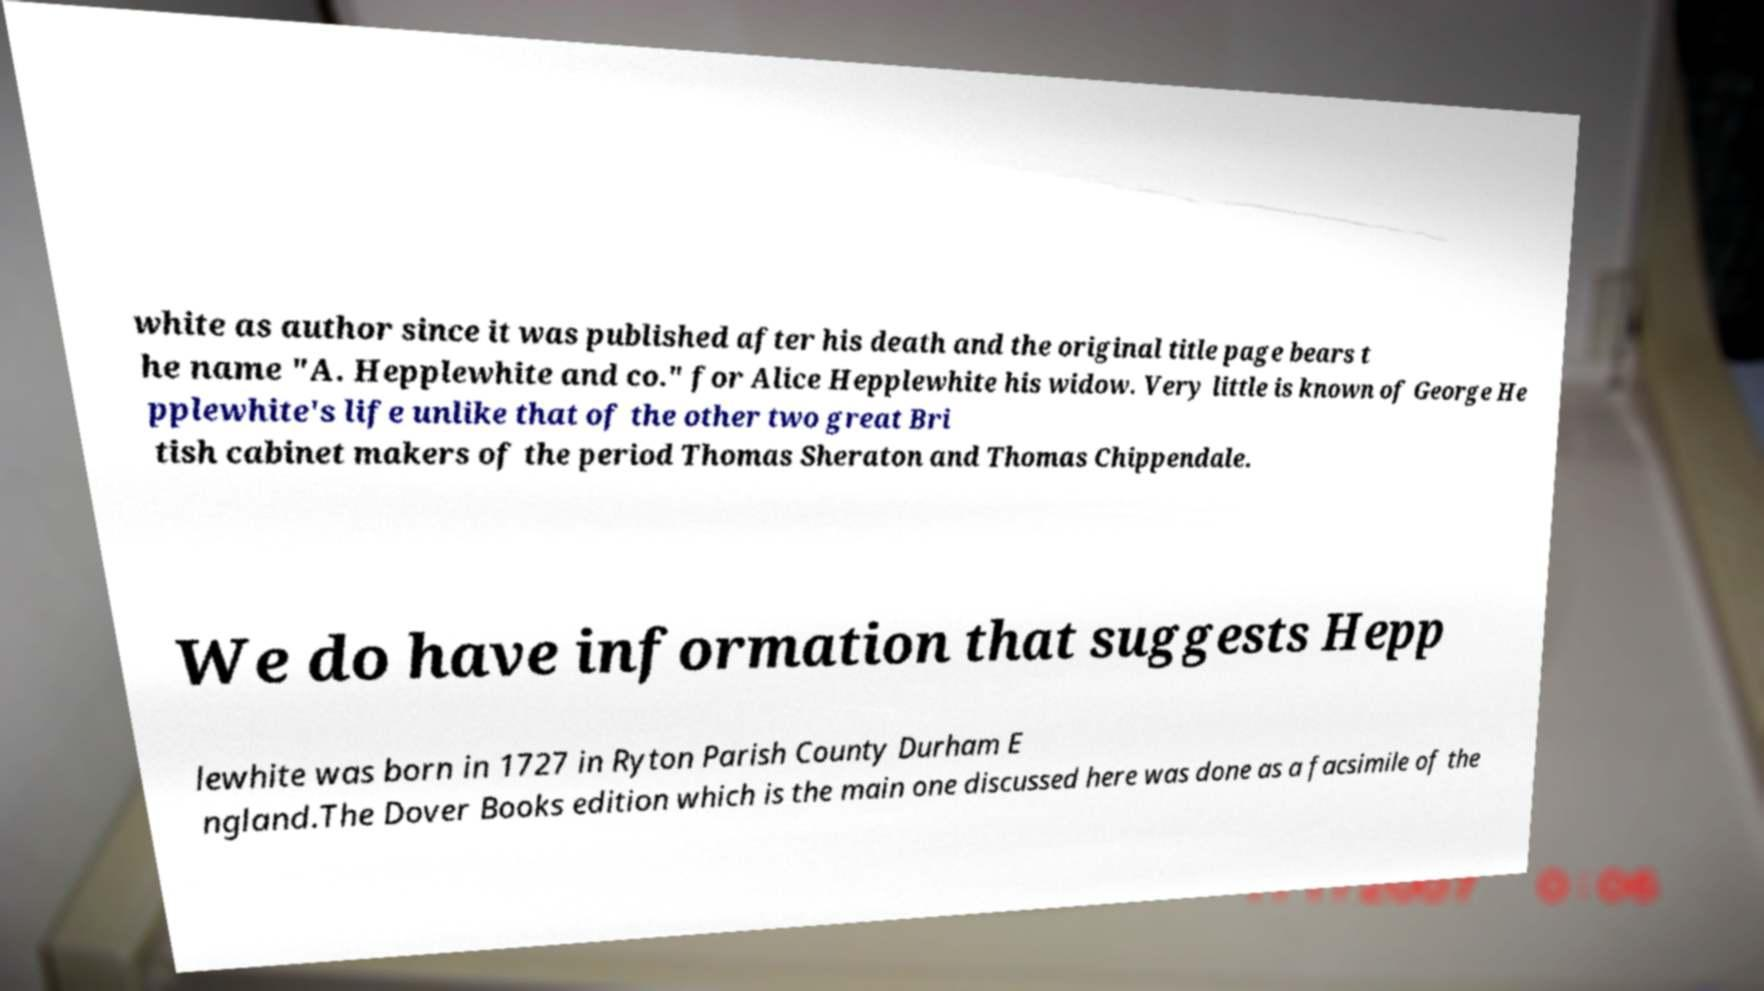Can you accurately transcribe the text from the provided image for me? white as author since it was published after his death and the original title page bears t he name "A. Hepplewhite and co." for Alice Hepplewhite his widow. Very little is known of George He pplewhite's life unlike that of the other two great Bri tish cabinet makers of the period Thomas Sheraton and Thomas Chippendale. We do have information that suggests Hepp lewhite was born in 1727 in Ryton Parish County Durham E ngland.The Dover Books edition which is the main one discussed here was done as a facsimile of the 